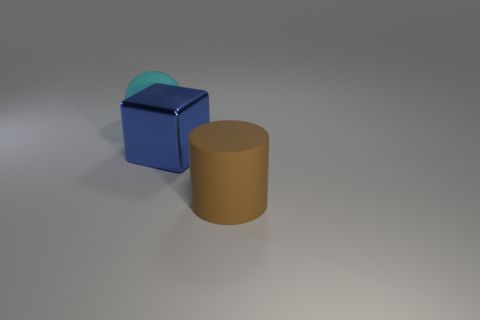Is there any other thing that is made of the same material as the blue thing?
Your response must be concise. No. Are there any other things that are the same shape as the brown object?
Your response must be concise. No. Are there an equal number of big blocks that are behind the big cyan matte sphere and matte balls in front of the large cylinder?
Your response must be concise. Yes. There is a ball that is made of the same material as the big brown cylinder; what color is it?
Ensure brevity in your answer.  Cyan. Is there a brown object made of the same material as the big brown cylinder?
Provide a succinct answer. No. What number of objects are small brown cylinders or large spheres?
Your answer should be very brief. 1. Is the cylinder made of the same material as the big thing on the left side of the blue block?
Provide a succinct answer. Yes. There is a matte object that is behind the matte cylinder; how big is it?
Make the answer very short. Large. Is the number of large blocks less than the number of small yellow shiny things?
Your answer should be compact. No. Are there any large metal cubes that have the same color as the large shiny object?
Your answer should be very brief. No. 